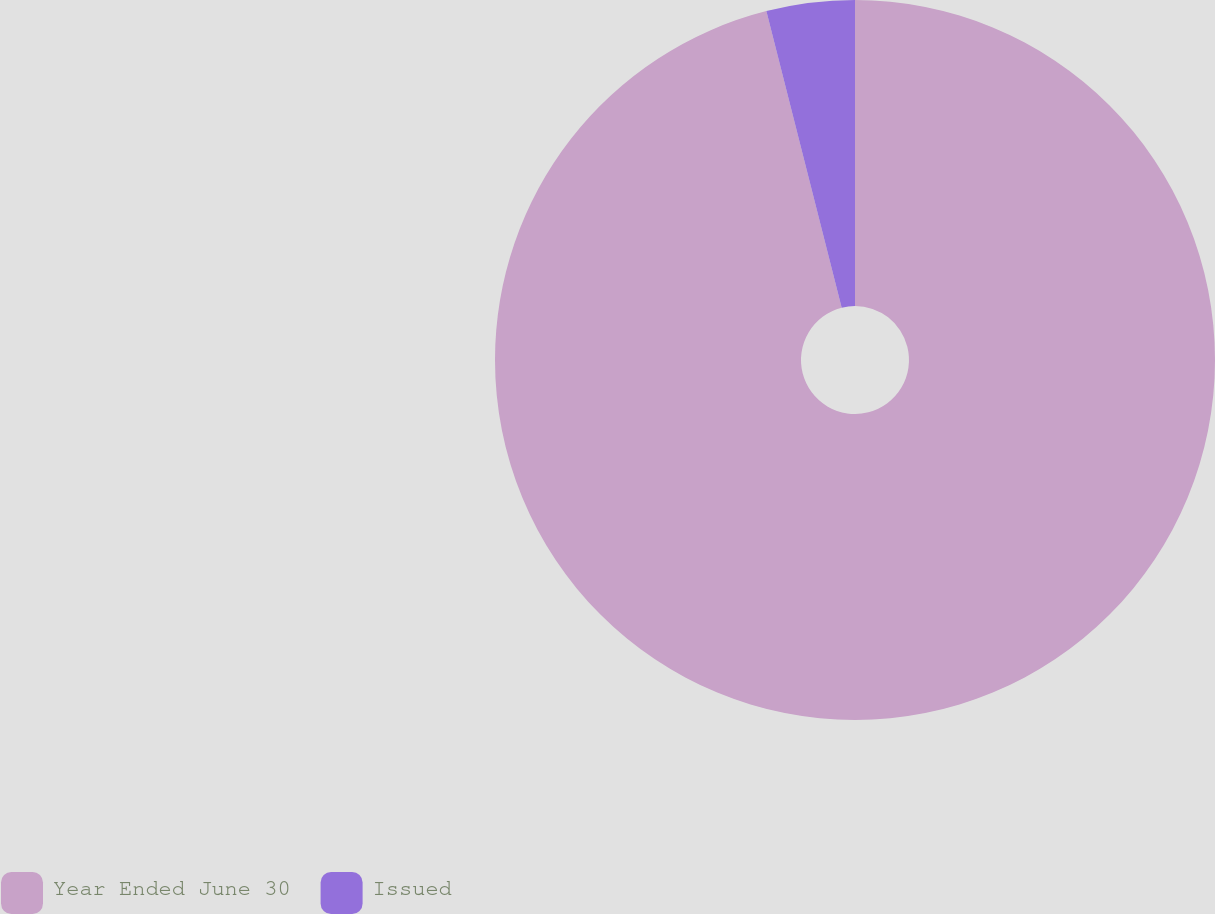Convert chart to OTSL. <chart><loc_0><loc_0><loc_500><loc_500><pie_chart><fcel>Year Ended June 30<fcel>Issued<nl><fcel>96.04%<fcel>3.96%<nl></chart> 